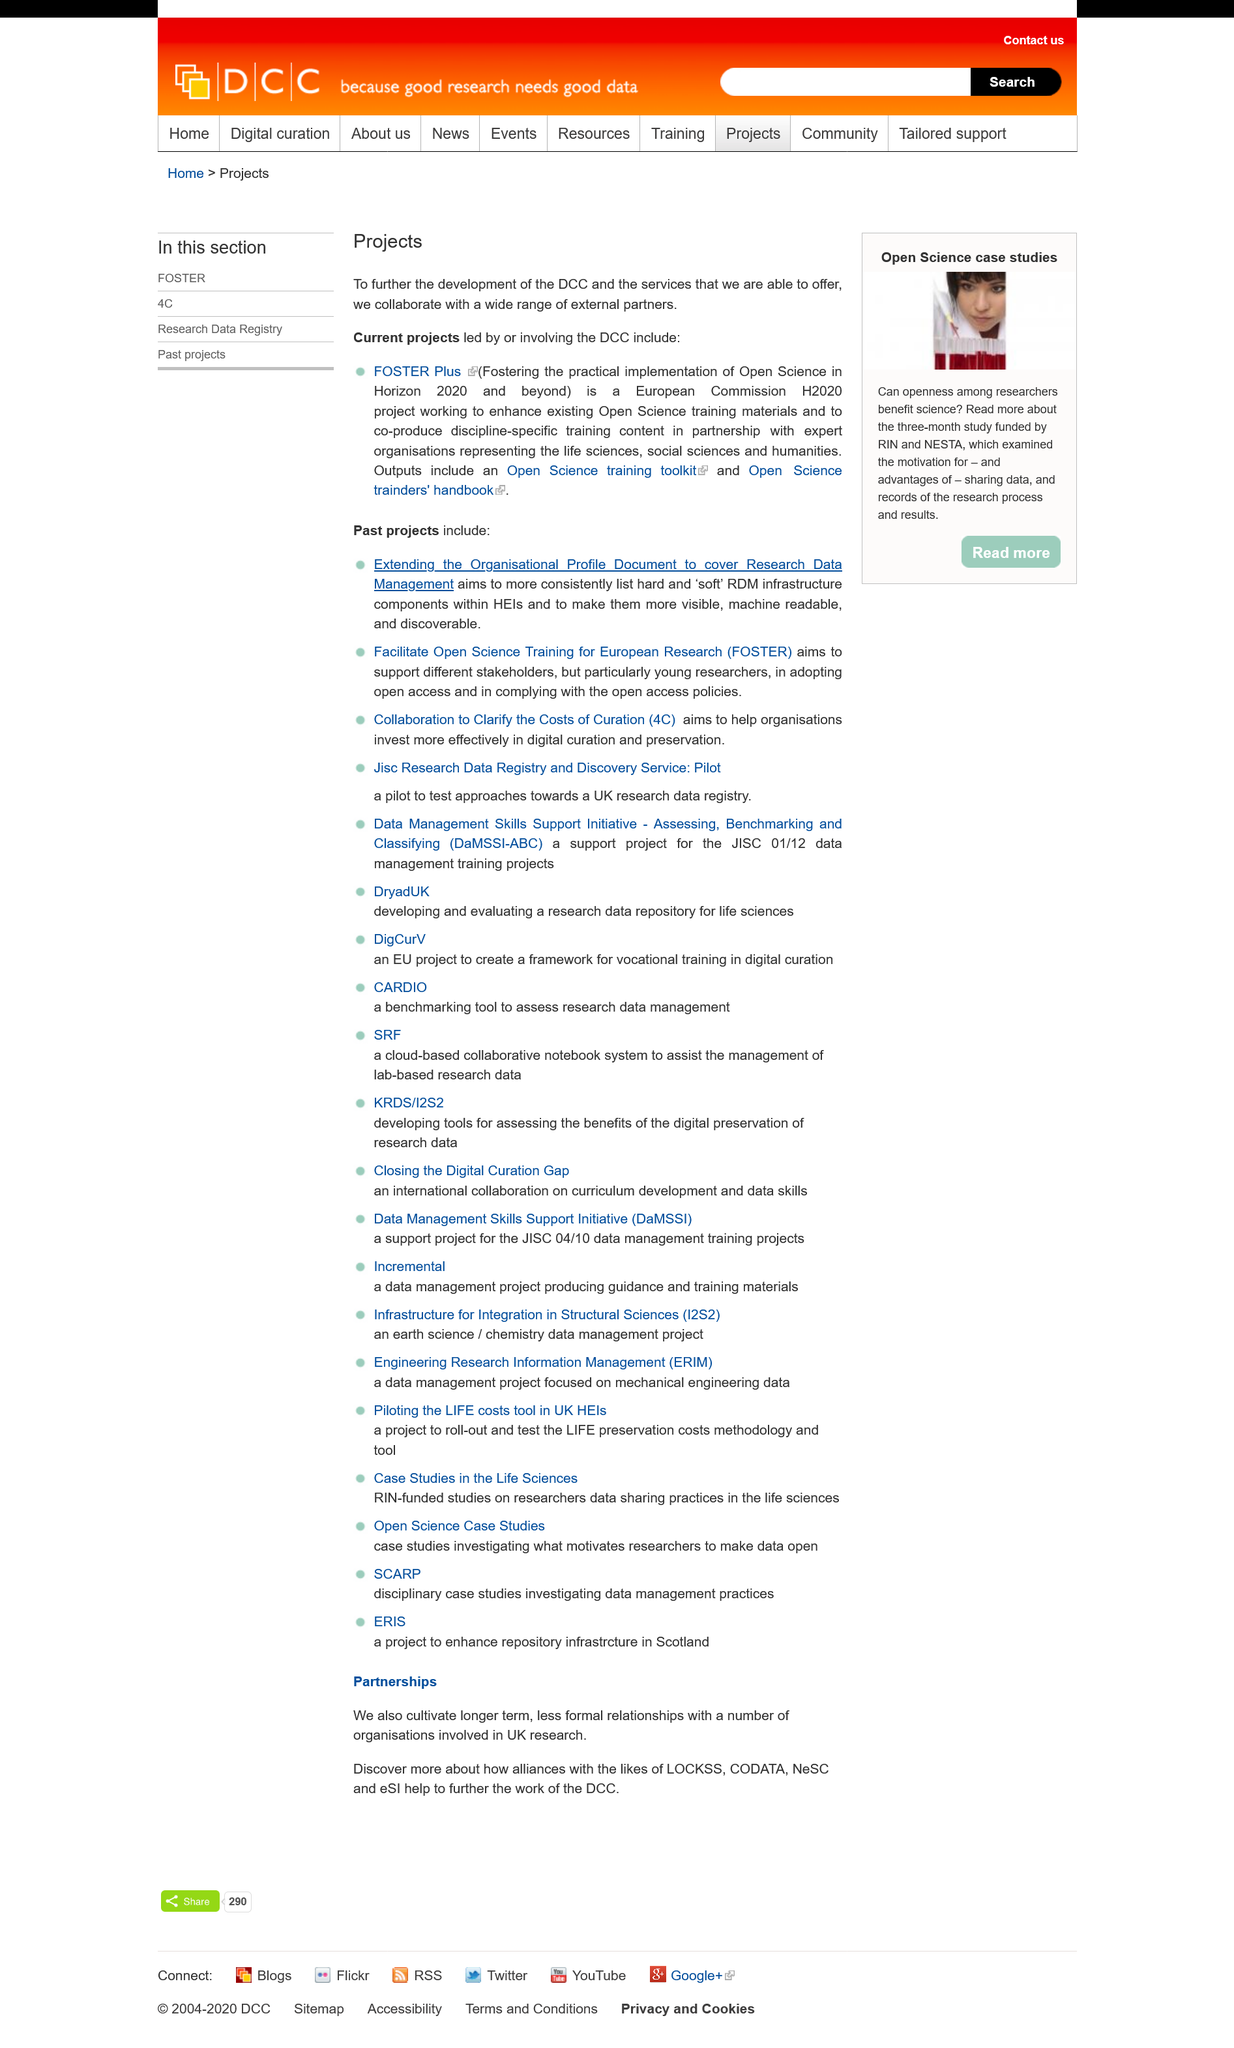List a handful of essential elements in this visual. FOSTER Plus is working to improve and create new Open Science training resources for different fields, by enhancing existing materials and collaborating with experts in each discipline to develop customized training content. The current project led or involving the DCC, FOSTER Plus, is currently ongoing. FOSTER Plus is a European Commission-funded project that aims to provide a comprehensive set of guidelines and tools to support the implementation of Future Internet Public Private Partnerships (PPPs) by facilitating open, interoperable, and inclusive collaborative innovation ecosystems. 